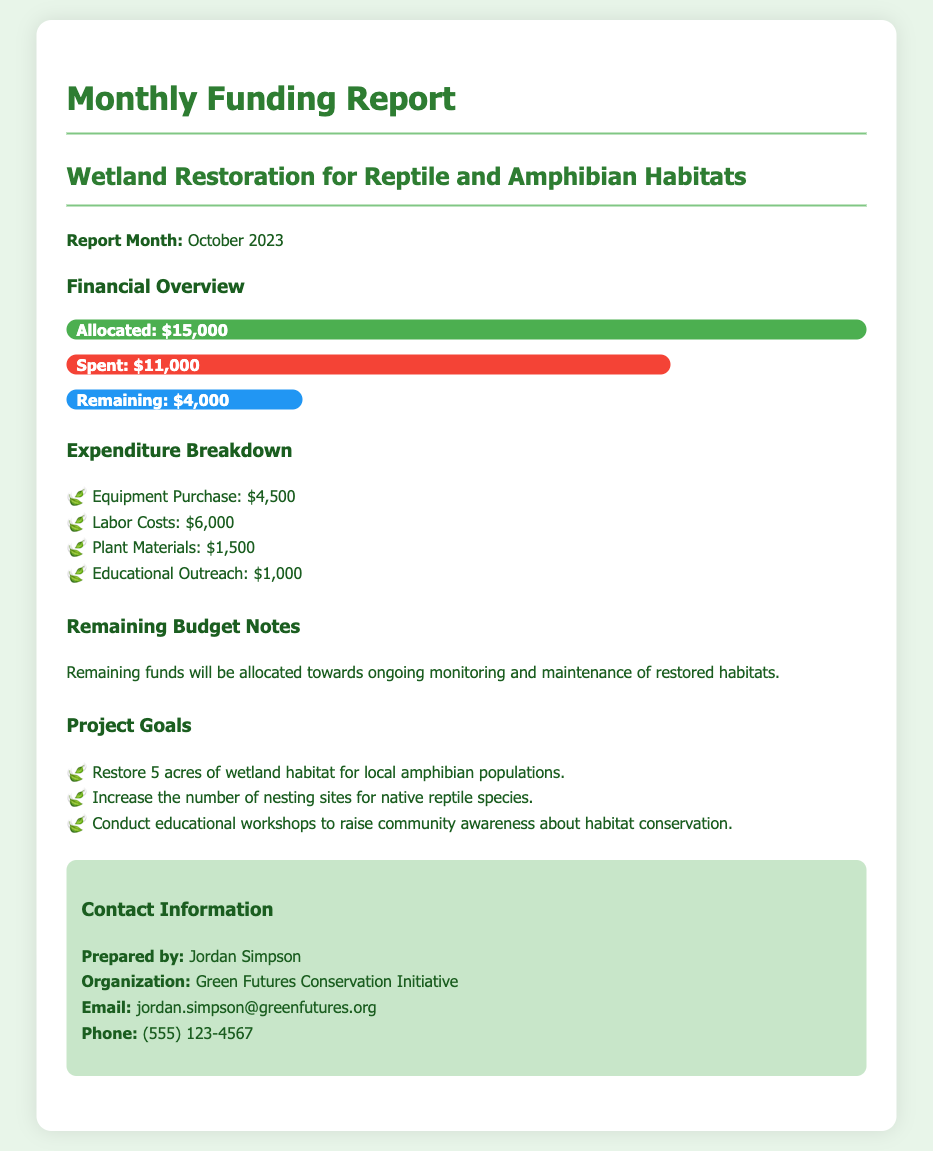what is the total allocated funding? The total allocated funding is stated clearly in the financial overview section as $15,000.
Answer: $15,000 how much has been spent so far? The amount spent is specified in the financial overview section as $11,000.
Answer: $11,000 what is the remaining budget? The document outlines the remaining budget as $4,000 in the financial overview.
Answer: $4,000 who prepared the report? The name of the person who prepared the report is mentioned in the contact information section as Jordan Simpson.
Answer: Jordan Simpson what is one of the project goals? The document lists various project goals, one example is to "Restore 5 acres of wetland habitat for local amphibian populations."
Answer: Restore 5 acres of wetland habitat for local amphibian populations how much was spent on labor costs? The expenditure breakdown specifies that labor costs amounted to $6,000.
Answer: $6,000 what percentage of the allocated funds has been spent? The spent amount of $11,000 is 73% of the allocated $15,000, as shown in the financial overview.
Answer: 73% what will the remaining funds be used for? The document notes that the remaining funds will be used for ongoing monitoring and maintenance of restored habitats.
Answer: Ongoing monitoring and maintenance of restored habitats how many acres of wetland habitat are targeted for restoration? The project aims to restore 5 acres of wetland habitat, which is mentioned in the project goals section.
Answer: 5 acres 